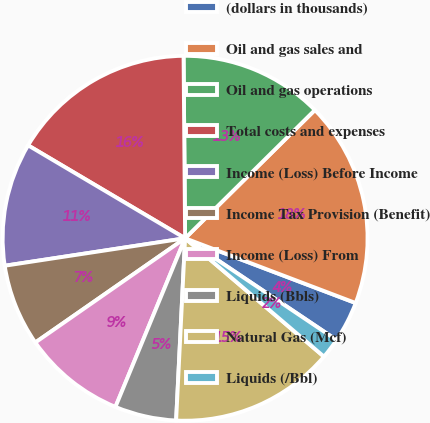<chart> <loc_0><loc_0><loc_500><loc_500><pie_chart><fcel>(dollars in thousands)<fcel>Oil and gas sales and<fcel>Oil and gas operations<fcel>Total costs and expenses<fcel>Income (Loss) Before Income<fcel>Income Tax Provision (Benefit)<fcel>Income (Loss) From<fcel>Liquids (Bbls)<fcel>Natural Gas (Mcf)<fcel>Liquids (/Bbl)<nl><fcel>3.64%<fcel>18.18%<fcel>12.73%<fcel>16.36%<fcel>10.91%<fcel>7.27%<fcel>9.09%<fcel>5.45%<fcel>14.55%<fcel>1.82%<nl></chart> 